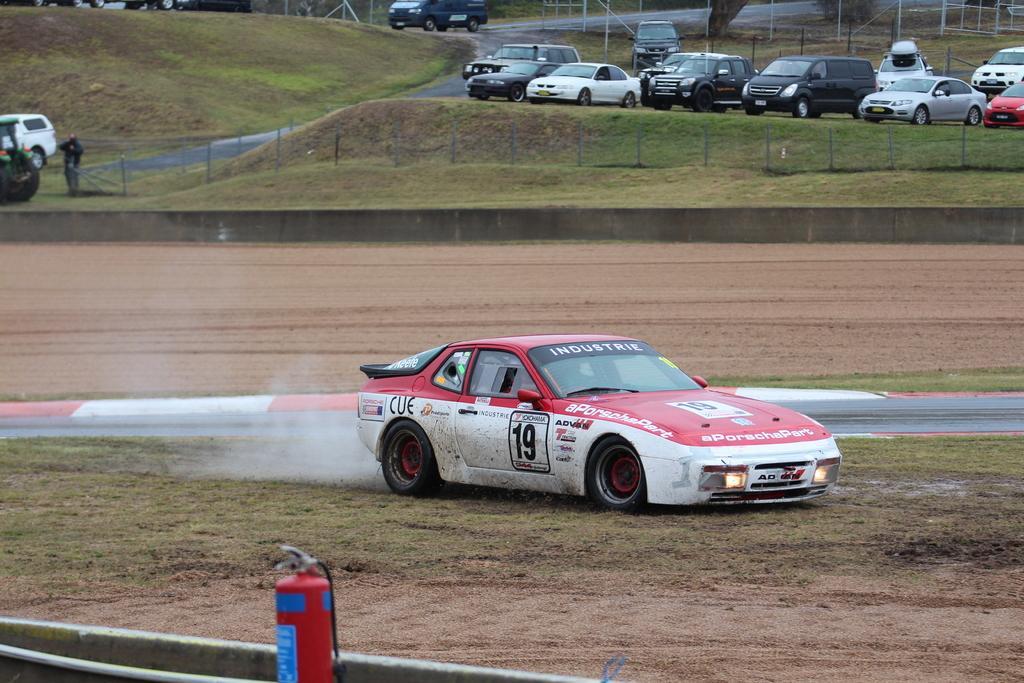Please provide a concise description of this image. In this image there is a ground, on the ground there are few vehicles, there is a person visible in front of the vehicle on the left side, at the bottom there is a cylinder, at the top there are some poles, road visible. 